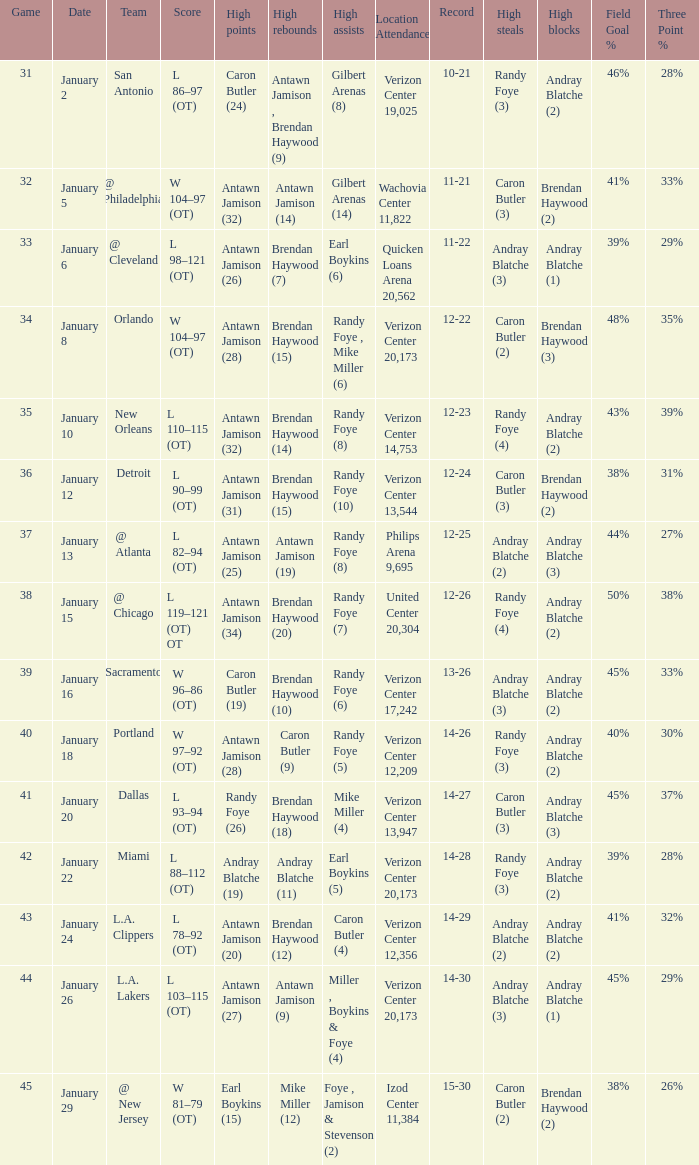How many people got high points in game 35? 1.0. 